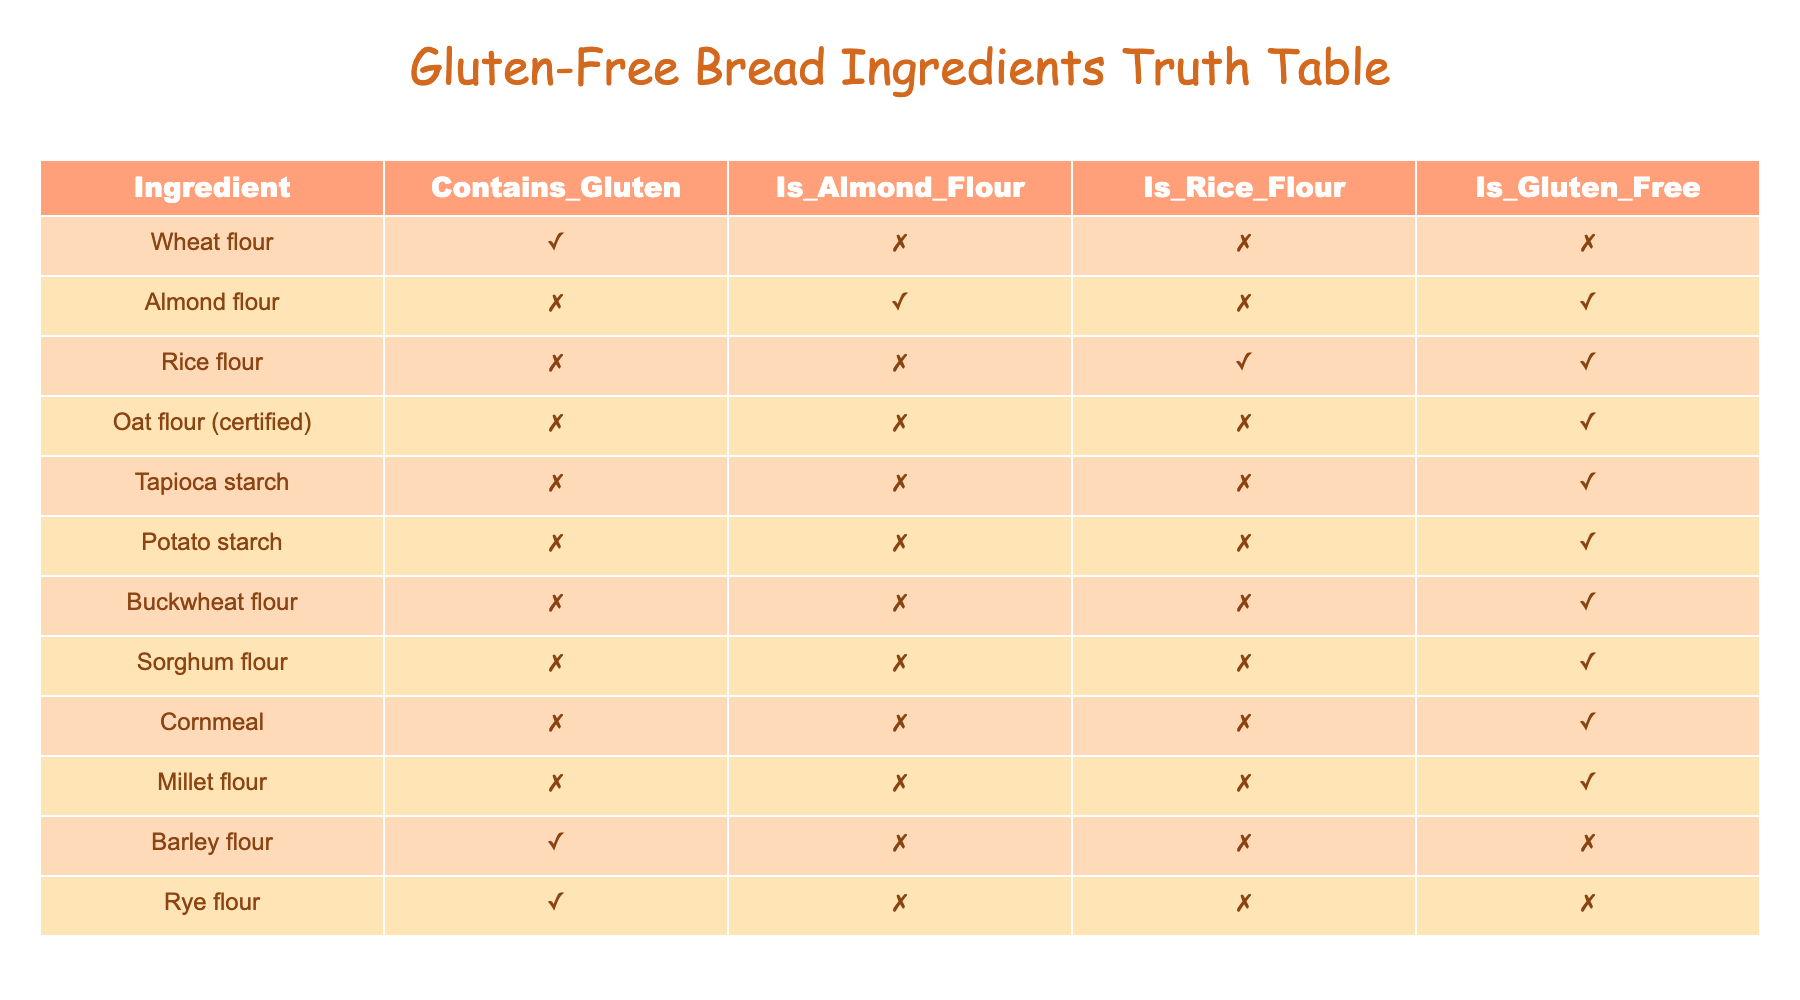What ingredient contains gluten? Referring to the "Contains_Gluten" column, I can see that both "Wheat flour," "Barley flour," and "Rye flour" have TRUE values. Therefore, these ingredients contain gluten.
Answer: Wheat flour, Barley flour, Rye flour Is almond flour gluten-free? Looking at the "Is_Gluten_Free" column for "Almond flour," the value is TRUE, indicating that almond flour is indeed gluten-free.
Answer: Yes How many ingredients are there that are gluten-free? By counting the rows where "Is_Gluten_Free" is TRUE, I find that there are 8 such ingredients in the table: Almond flour, Rice flour, Oat flour (certified), Tapioca starch, Potato starch, Buckwheat flour, Sorghum flour, Cornmeal, and Millet flour.
Answer: 8 Which ingredient is both gluten-free and made from rice flour? Only "Rice flour" has TRUE in the "Is_Rice_Flour" column and TRUE in "Is_Gluten_Free." Therefore, it is the only ingredient that meets both conditions.
Answer: Rice flour Are there any gluten-free ingredients that are also made from almond flour? The only entry with TRUE for "Is_Almond_Flour" is "Almond flour" itself, which is gluten-free (TRUE under "Is_Gluten_Free"). Hence, it is the answer to this question.
Answer: Yes, Almond flour What percentage of the listed ingredients are gluten-free? There are 14 total ingredients, and 8 are gluten-free. The percentage is (8/14) * 100 = approximately 57.14%.
Answer: 57.14% Is rye flour both gluten-free and contains gluten? The "Contains_Gluten" column shows TRUE for "Rye flour," while "Is_Gluten_Free" indicates FALSE. Therefore, rye flour cannot be gluten-free.
Answer: No How many flours in the table do not contain gluten? By counting the number of rows with FALSE in the "Contains_Gluten" column, I find 9 ingredients do not contain gluten.
Answer: 9 What is the total number of gluten-containing ingredients versus gluten-free ingredients? There are 6 ingredients that contain gluten, and 8 that are gluten-free; thus, the total for gluten-containing ingredients is 6, and for gluten-free, it is 8.
Answer: 6 gluten-containing, 8 gluten-free 